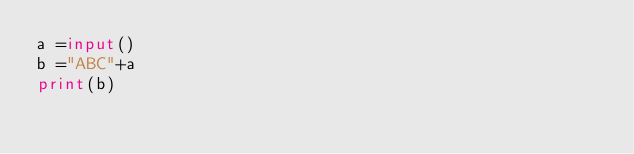<code> <loc_0><loc_0><loc_500><loc_500><_Python_>a =input()
b ="ABC"+a
print(b)</code> 